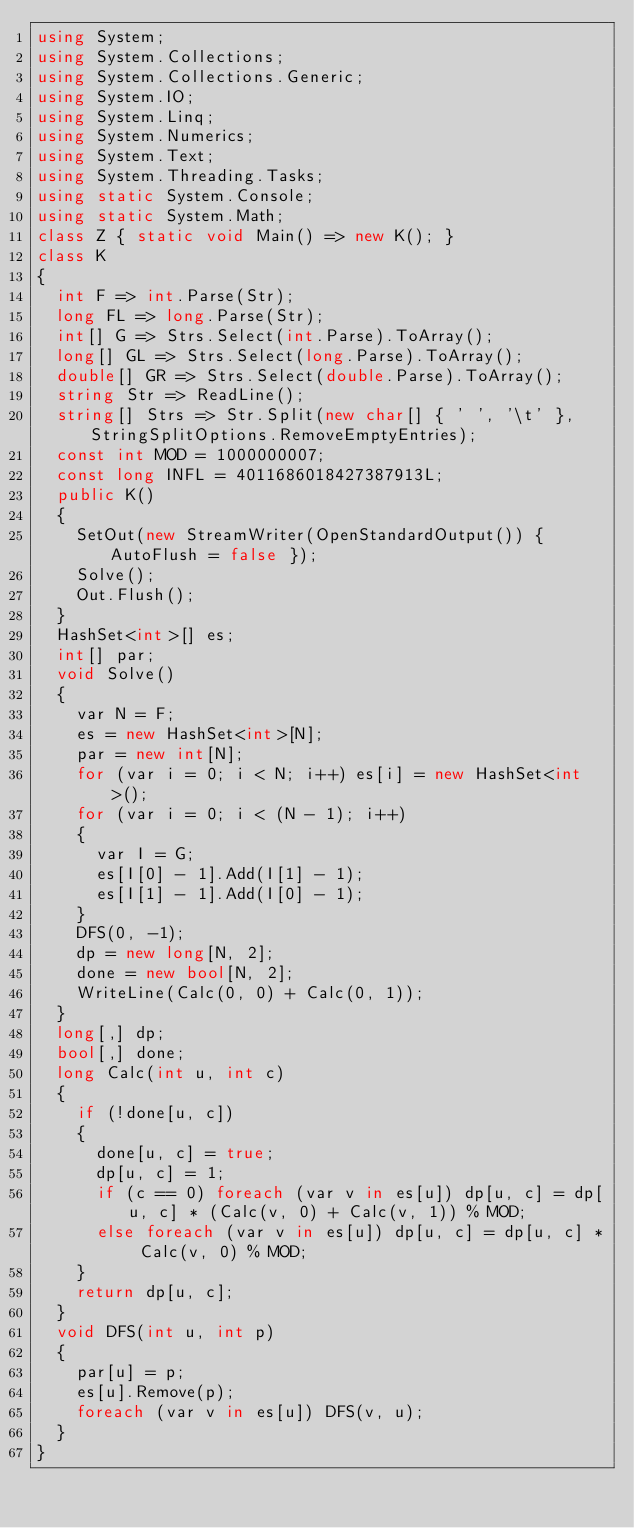Convert code to text. <code><loc_0><loc_0><loc_500><loc_500><_C#_>using System;
using System.Collections;
using System.Collections.Generic;
using System.IO;
using System.Linq;
using System.Numerics;
using System.Text;
using System.Threading.Tasks;
using static System.Console;
using static System.Math;
class Z { static void Main() => new K(); }
class K
{
	int F => int.Parse(Str);
	long FL => long.Parse(Str);
	int[] G => Strs.Select(int.Parse).ToArray();
	long[] GL => Strs.Select(long.Parse).ToArray();
	double[] GR => Strs.Select(double.Parse).ToArray();
	string Str => ReadLine();
	string[] Strs => Str.Split(new char[] { ' ', '\t' }, StringSplitOptions.RemoveEmptyEntries);
	const int MOD = 1000000007;
	const long INFL = 4011686018427387913L;
	public K()
	{
		SetOut(new StreamWriter(OpenStandardOutput()) { AutoFlush = false });
		Solve();
		Out.Flush();
	}
	HashSet<int>[] es;
	int[] par;
	void Solve()
	{
		var N = F;
		es = new HashSet<int>[N];
		par = new int[N];
		for (var i = 0; i < N; i++) es[i] = new HashSet<int>();
		for (var i = 0; i < (N - 1); i++)
		{
			var I = G;
			es[I[0] - 1].Add(I[1] - 1);
			es[I[1] - 1].Add(I[0] - 1);
		}
		DFS(0, -1);
		dp = new long[N, 2];
		done = new bool[N, 2];
		WriteLine(Calc(0, 0) + Calc(0, 1));
	}
	long[,] dp;
	bool[,] done;
	long Calc(int u, int c)
	{
		if (!done[u, c])
		{
			done[u, c] = true;
			dp[u, c] = 1;
			if (c == 0) foreach (var v in es[u]) dp[u, c] = dp[u, c] * (Calc(v, 0) + Calc(v, 1)) % MOD;
			else foreach (var v in es[u]) dp[u, c] = dp[u, c] * Calc(v, 0) % MOD;
		}
		return dp[u, c];
	}
	void DFS(int u, int p)
	{
		par[u] = p;
		es[u].Remove(p);
		foreach (var v in es[u]) DFS(v, u);
	}
}
</code> 